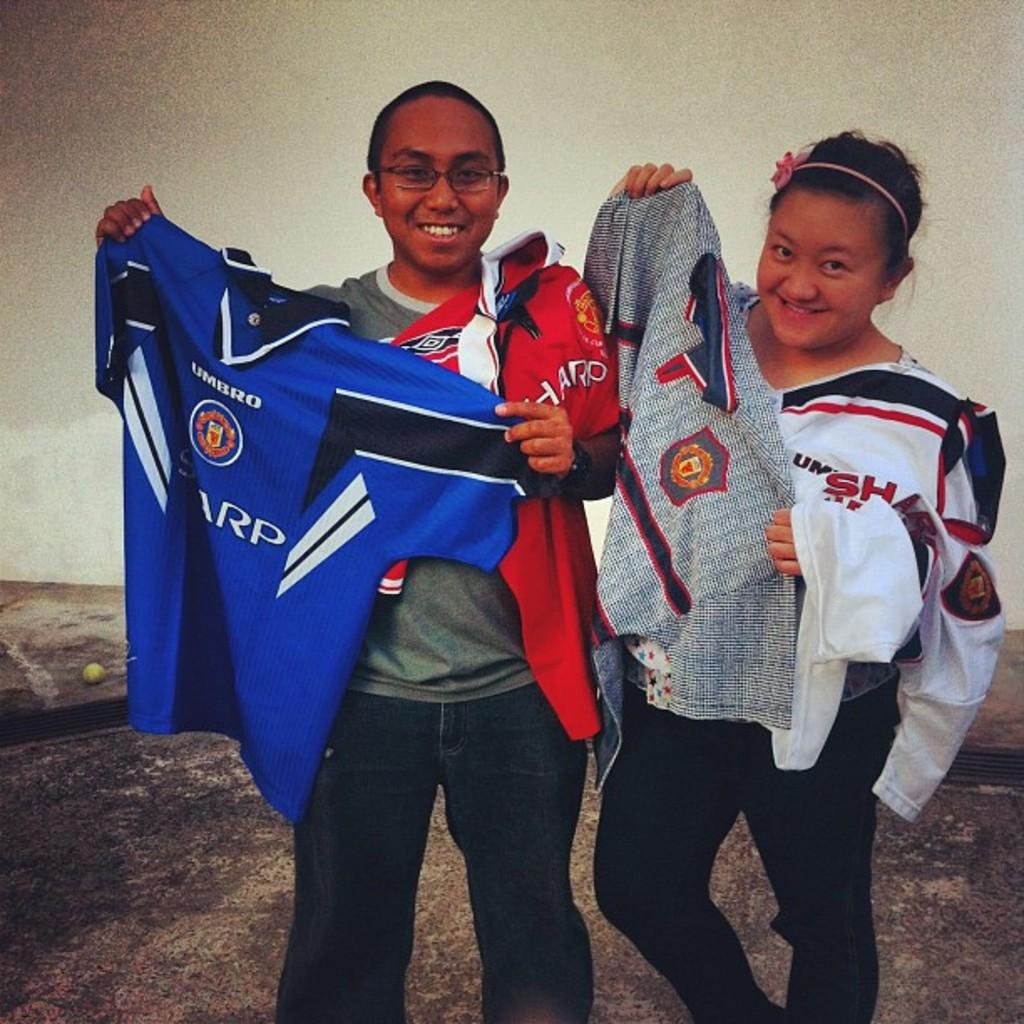What are the persons in the image doing? The persons in the image are standing on the ground and holding clothes. What might the persons be doing with the clothes they are holding? They might be hanging or arranging the clothes on a clothesline or in a designated area. Can you describe the background of the image? There is an object and a wall in the background of the image. What type of cushion can be seen in the image? There is no cushion present in the image. What do the persons in the image believe about the clothes they are holding? The image does not provide information about the beliefs of the persons regarding the clothes they are holding. 